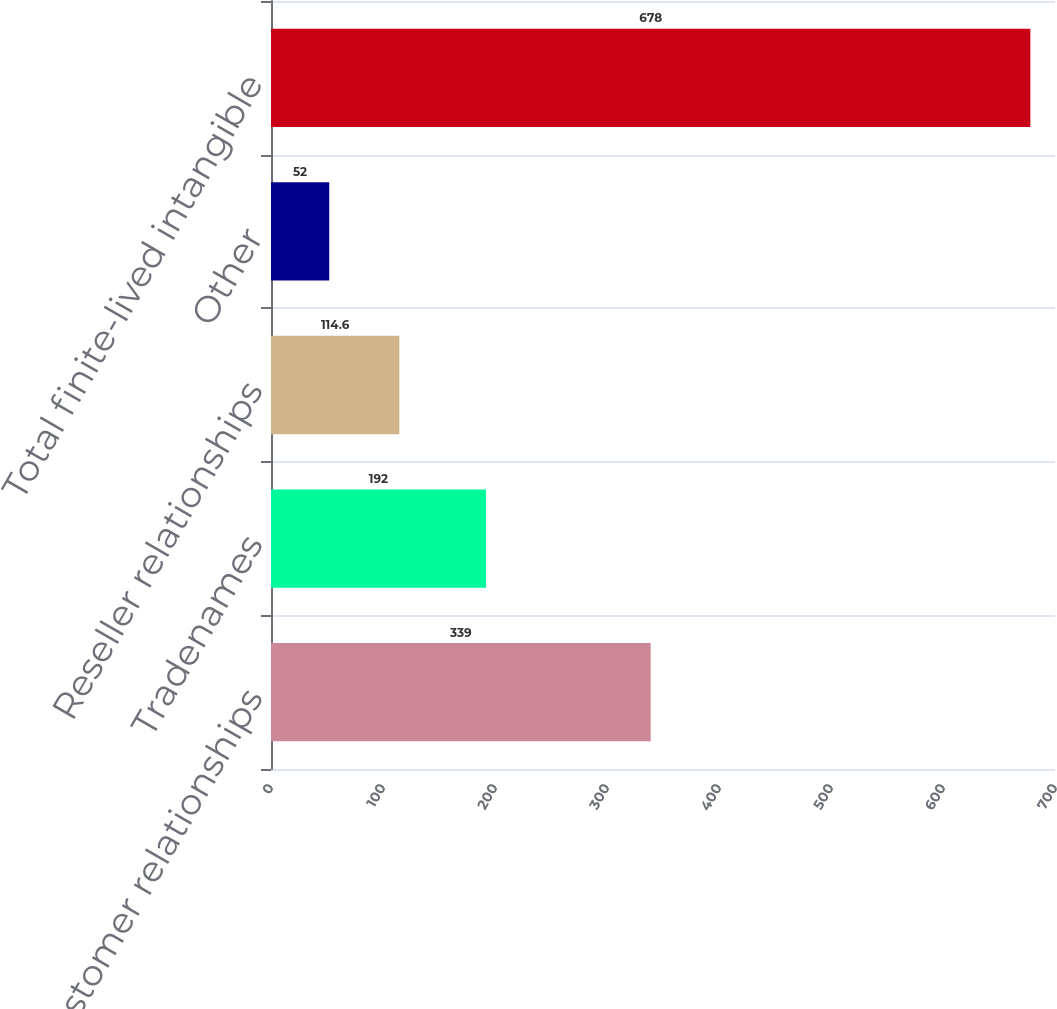<chart> <loc_0><loc_0><loc_500><loc_500><bar_chart><fcel>Customer relationships<fcel>Tradenames<fcel>Reseller relationships<fcel>Other<fcel>Total finite-lived intangible<nl><fcel>339<fcel>192<fcel>114.6<fcel>52<fcel>678<nl></chart> 